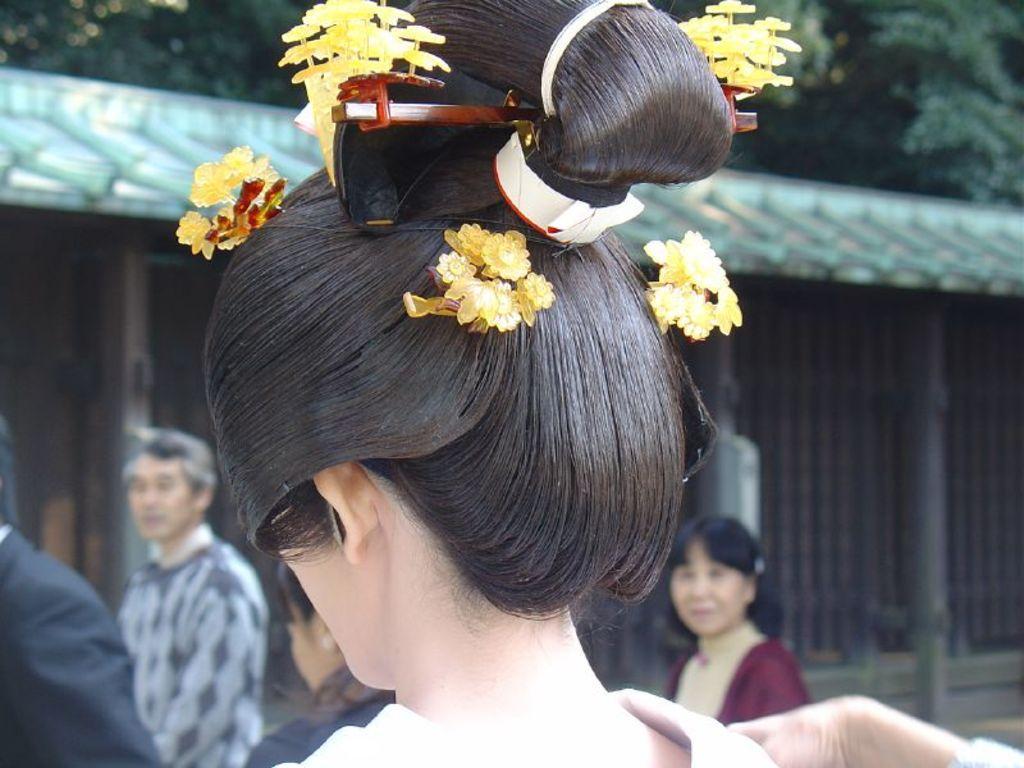What is the main subject of the image? There is a doll in the image. What is unique about the doll's appearance? The doll is wearing artificial flowers on its hair. What can be seen in the background of the image? There are people, trees, and sheds in the background of the image. What type of bone can be seen in the doll's hand in the image? There is no bone present in the image; the doll is not holding any object, including a bone. 